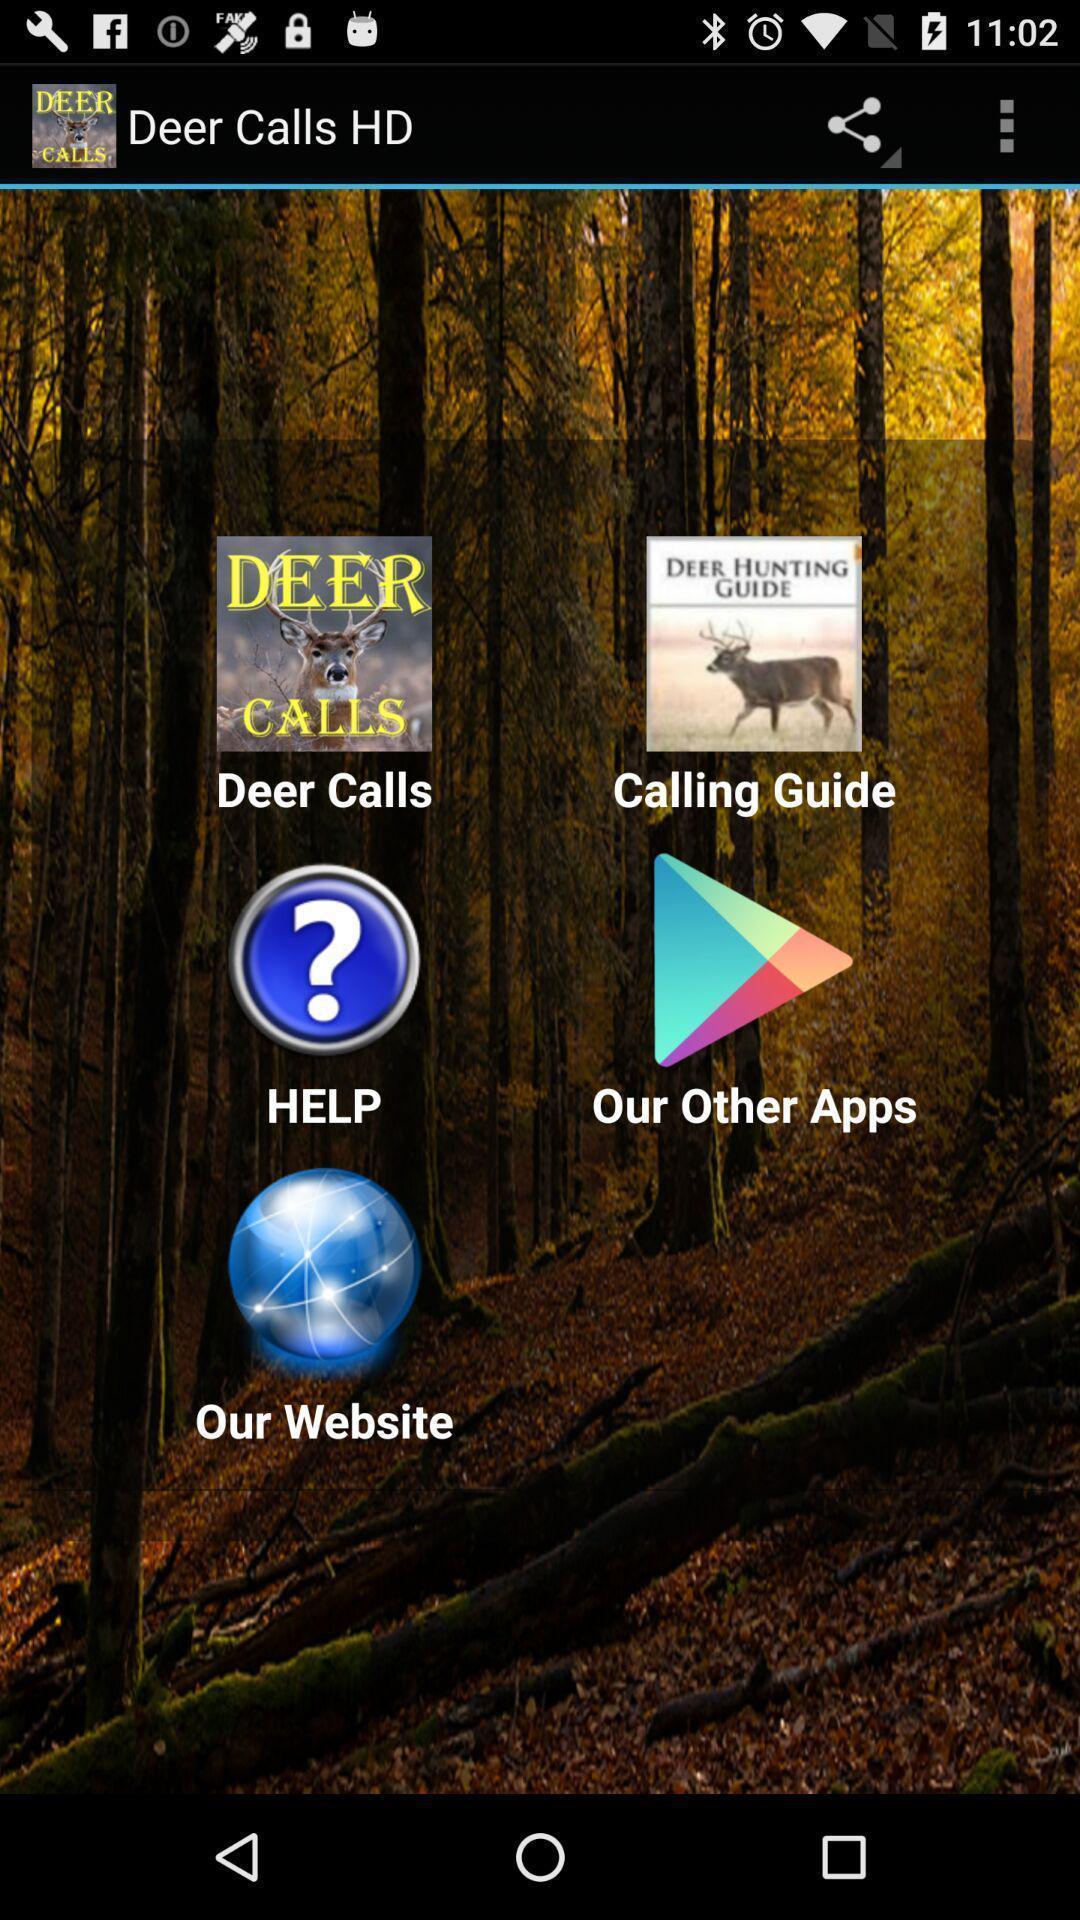Give me a narrative description of this picture. Popup of different applications to utilize. 